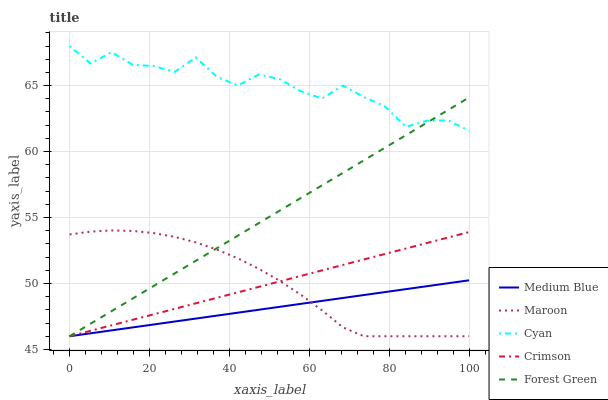Does Forest Green have the minimum area under the curve?
Answer yes or no. No. Does Forest Green have the maximum area under the curve?
Answer yes or no. No. Is Cyan the smoothest?
Answer yes or no. No. Is Forest Green the roughest?
Answer yes or no. No. Does Cyan have the lowest value?
Answer yes or no. No. Does Forest Green have the highest value?
Answer yes or no. No. Is Crimson less than Cyan?
Answer yes or no. Yes. Is Cyan greater than Crimson?
Answer yes or no. Yes. Does Crimson intersect Cyan?
Answer yes or no. No. 